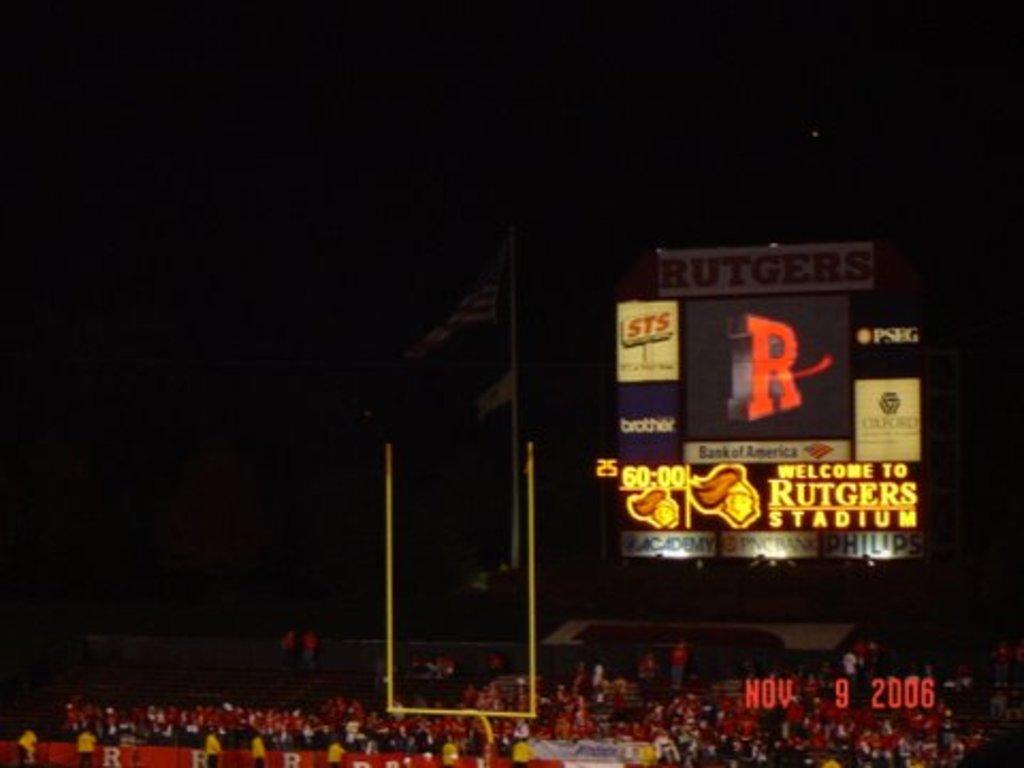What is the main subject of the image? The main subject of the image is a crowd. What can be seen in the image besides the crowd? There is a yellow stand, digital hoardings, and a flag in the image. How would you describe the background of the image? The background of the image is dark. What type of bone is visible in the image? There is no bone present in the image. What news can be heard from the yellow stand in the image? The image does not provide any information about news or audio, so it cannot be determined from the image. 